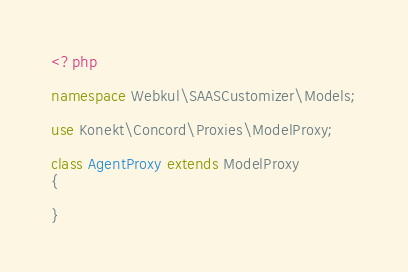<code> <loc_0><loc_0><loc_500><loc_500><_PHP_><?php

namespace Webkul\SAASCustomizer\Models;

use Konekt\Concord\Proxies\ModelProxy;

class AgentProxy extends ModelProxy
{

}</code> 